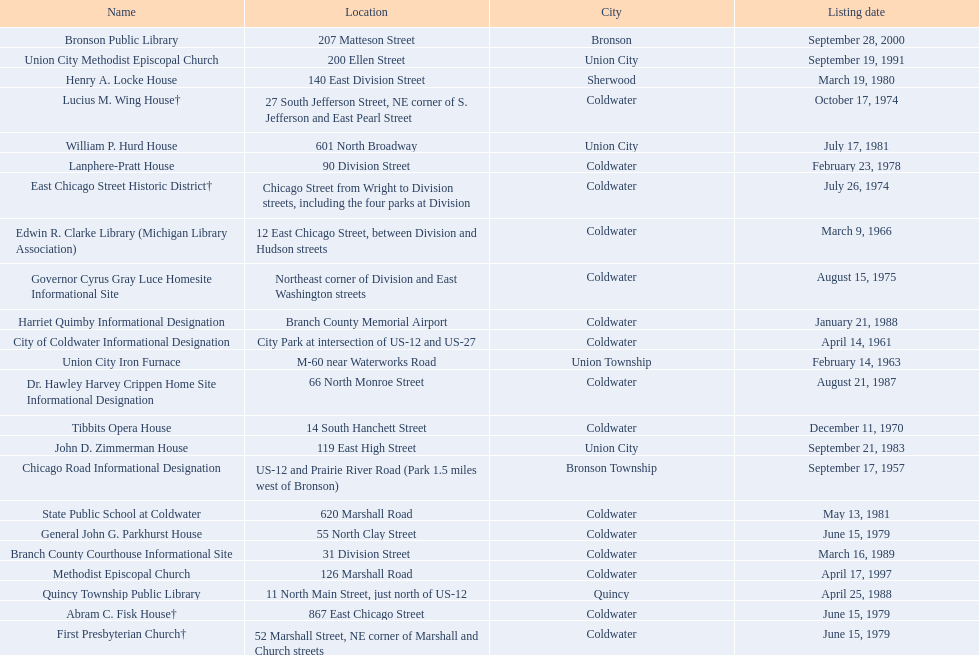What is the total current listing of names on this chart? 23. 